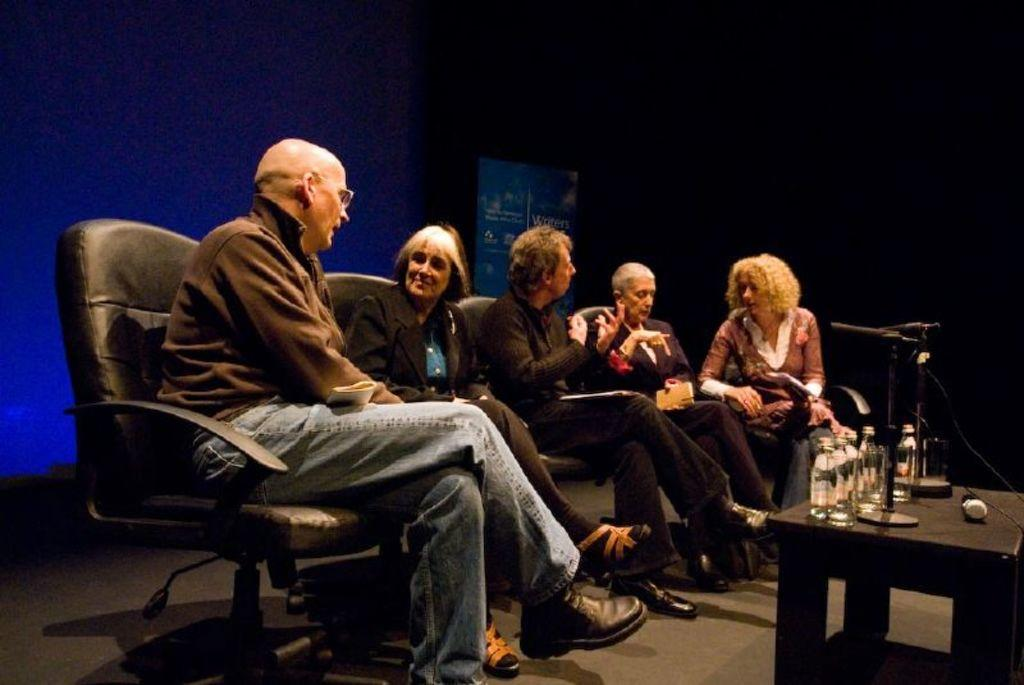How many people are in the image? There is a group of people in the image. What are the people doing in the image? The people are sitting on chairs. What is in front of the people? There is a table in front of the people. What can be seen on the table? There are bottles and other objects on the table. What type of crime is being committed in the image? There is no indication of any crime being committed in the image. How does the taste of the objects on the table compare to the taste of the chairs? The taste of the objects on the table and the chairs cannot be determined from the image, as taste is not a visual characteristic. 